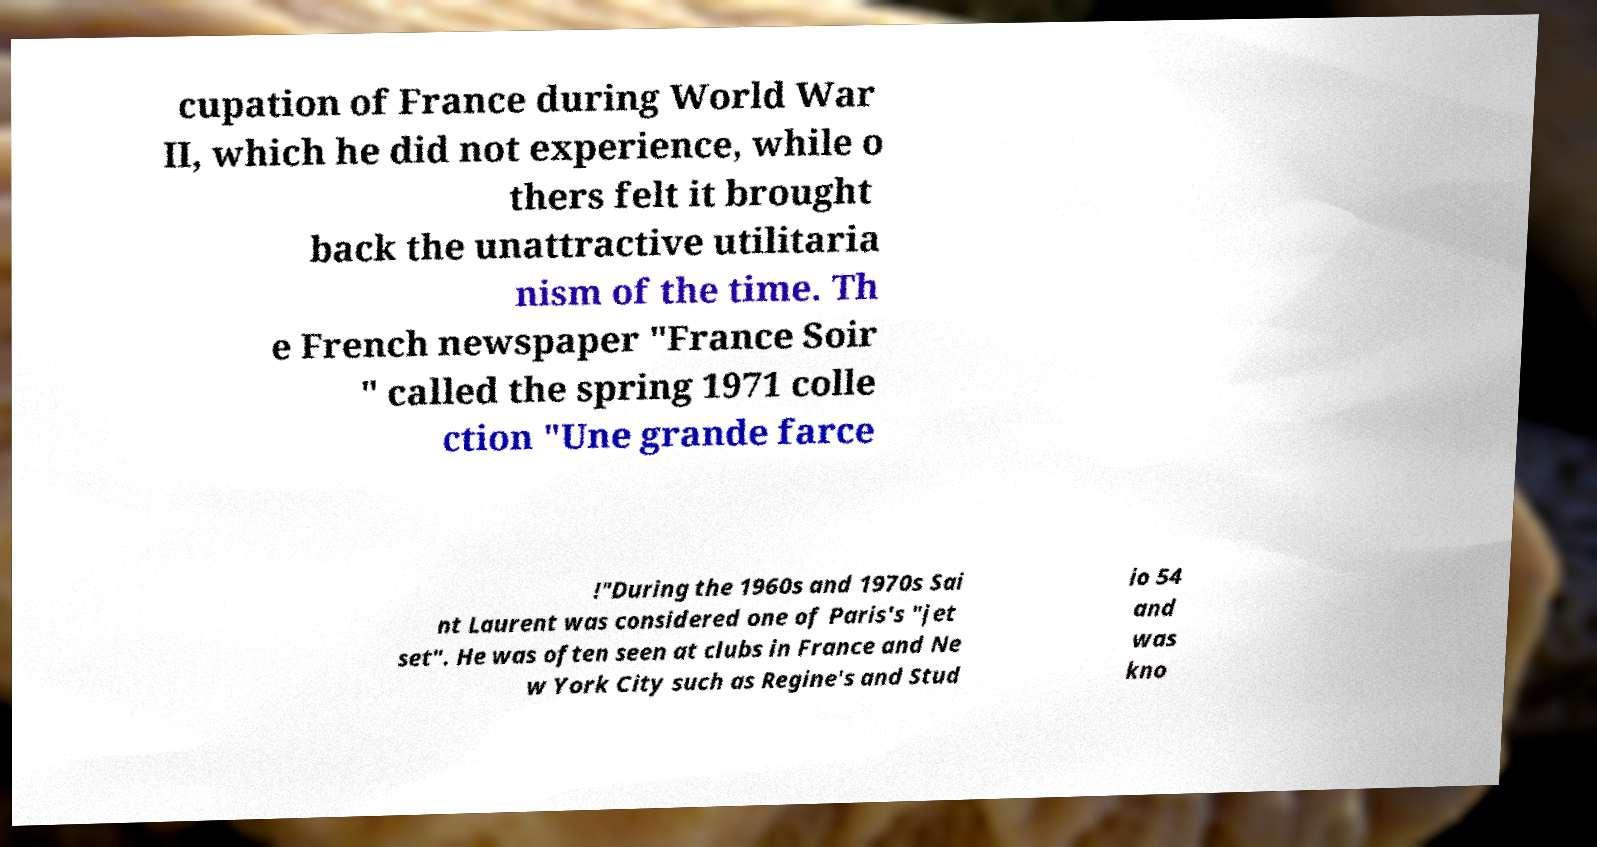What messages or text are displayed in this image? I need them in a readable, typed format. cupation of France during World War II, which he did not experience, while o thers felt it brought back the unattractive utilitaria nism of the time. Th e French newspaper "France Soir " called the spring 1971 colle ction "Une grande farce !"During the 1960s and 1970s Sai nt Laurent was considered one of Paris's "jet set". He was often seen at clubs in France and Ne w York City such as Regine's and Stud io 54 and was kno 